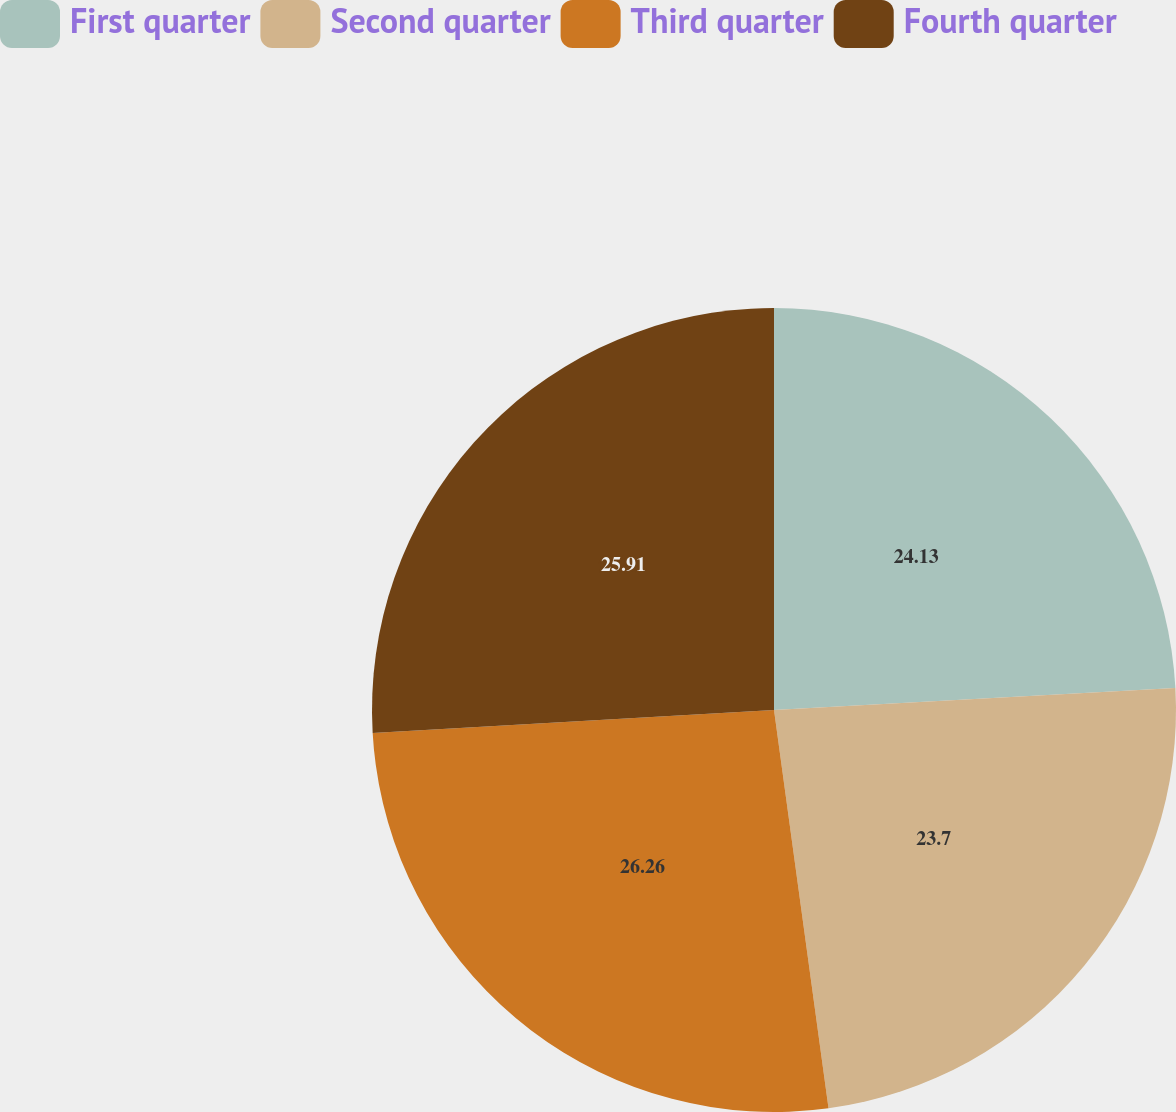<chart> <loc_0><loc_0><loc_500><loc_500><pie_chart><fcel>First quarter<fcel>Second quarter<fcel>Third quarter<fcel>Fourth quarter<nl><fcel>24.13%<fcel>23.7%<fcel>26.25%<fcel>25.91%<nl></chart> 